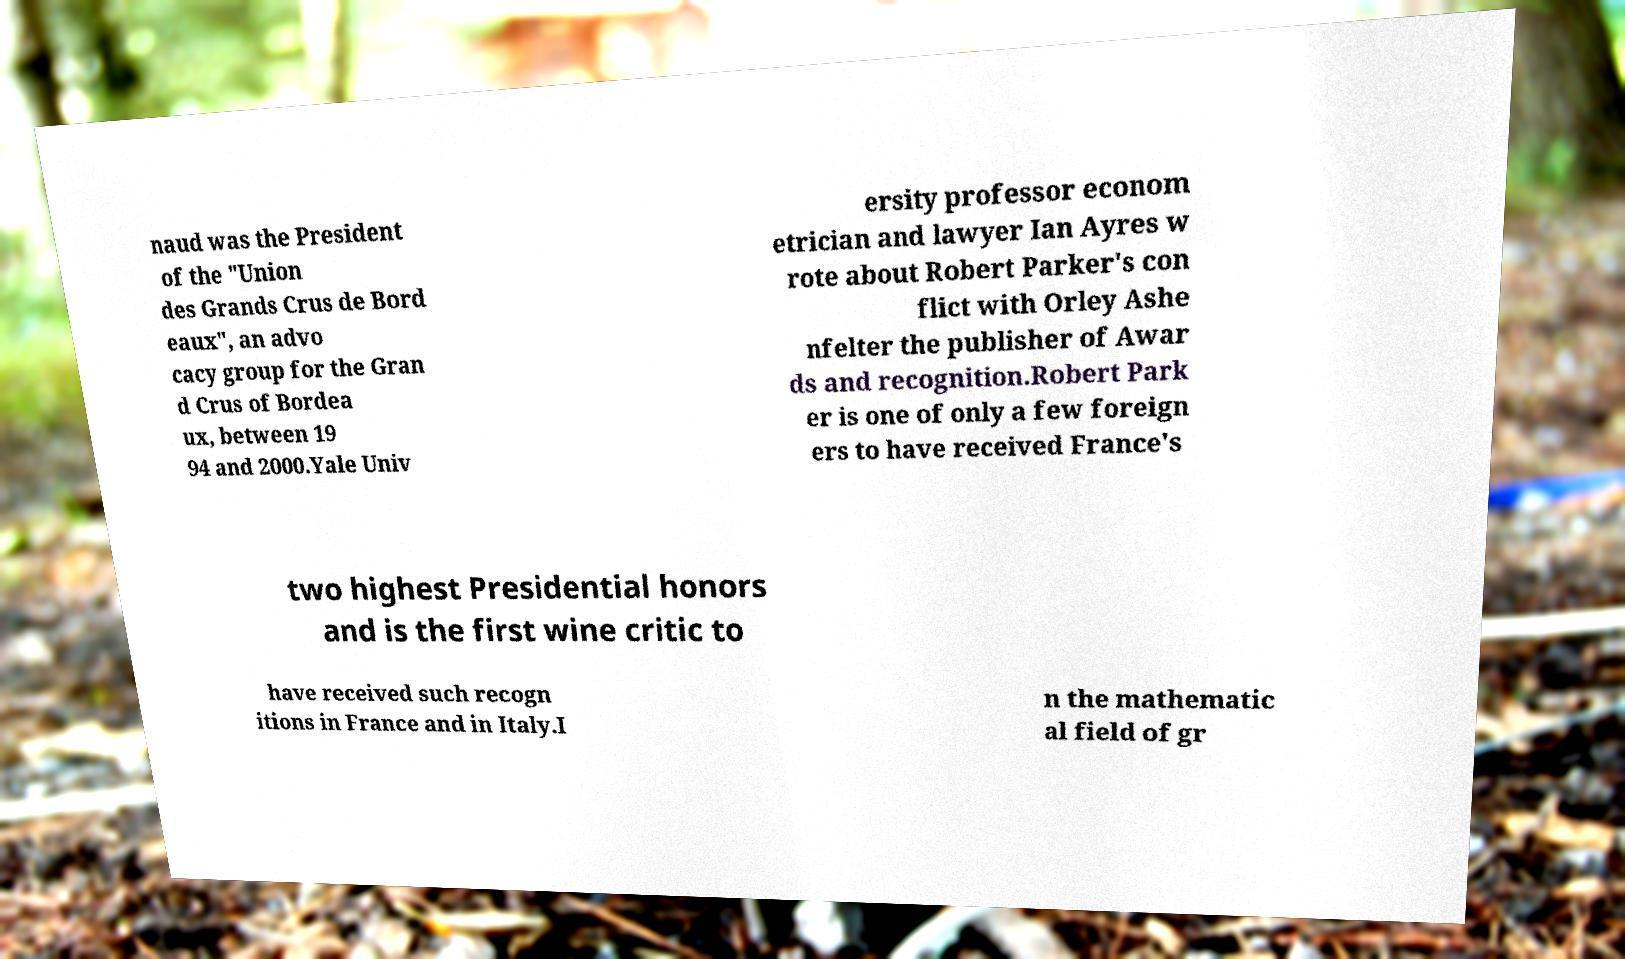Could you assist in decoding the text presented in this image and type it out clearly? naud was the President of the "Union des Grands Crus de Bord eaux", an advo cacy group for the Gran d Crus of Bordea ux, between 19 94 and 2000.Yale Univ ersity professor econom etrician and lawyer Ian Ayres w rote about Robert Parker's con flict with Orley Ashe nfelter the publisher of Awar ds and recognition.Robert Park er is one of only a few foreign ers to have received France's two highest Presidential honors and is the first wine critic to have received such recogn itions in France and in Italy.I n the mathematic al field of gr 